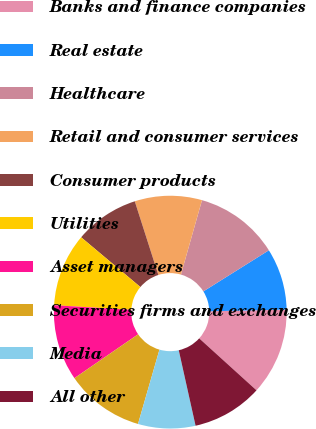<chart> <loc_0><loc_0><loc_500><loc_500><pie_chart><fcel>Banks and finance companies<fcel>Real estate<fcel>Healthcare<fcel>Retail and consumer services<fcel>Consumer products<fcel>Utilities<fcel>Asset managers<fcel>Securities firms and exchanges<fcel>Media<fcel>All other<nl><fcel>12.07%<fcel>8.57%<fcel>11.69%<fcel>9.33%<fcel>8.95%<fcel>10.17%<fcel>10.55%<fcel>10.93%<fcel>7.96%<fcel>9.79%<nl></chart> 